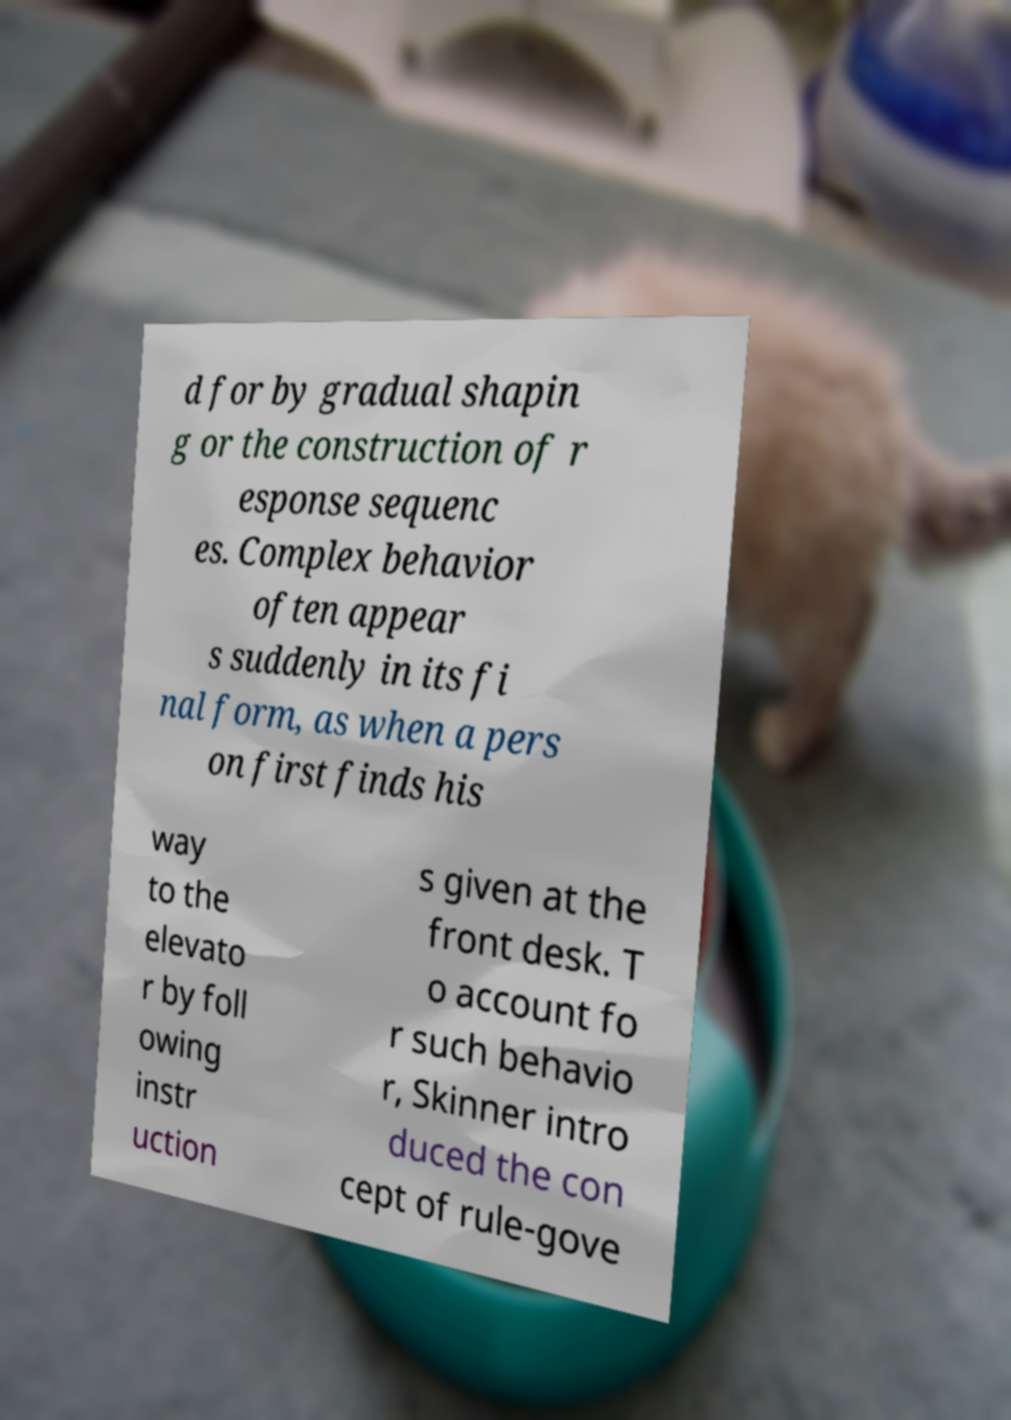Please identify and transcribe the text found in this image. d for by gradual shapin g or the construction of r esponse sequenc es. Complex behavior often appear s suddenly in its fi nal form, as when a pers on first finds his way to the elevato r by foll owing instr uction s given at the front desk. T o account fo r such behavio r, Skinner intro duced the con cept of rule-gove 